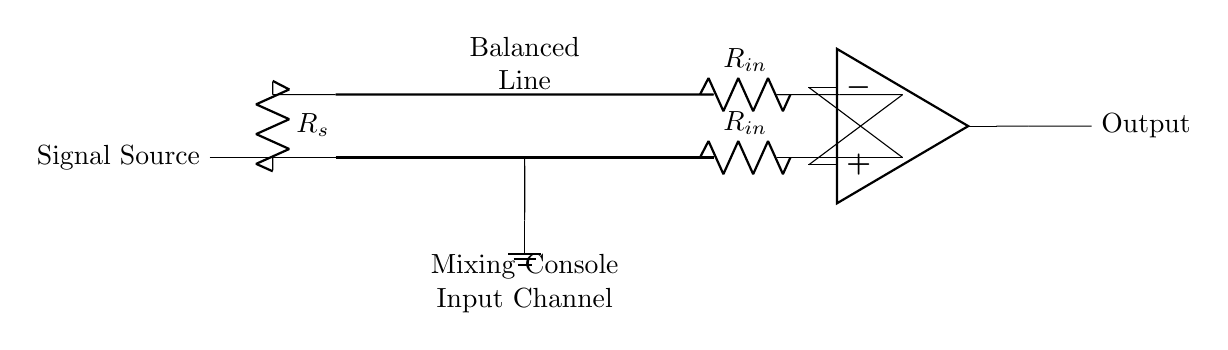What is the role of the resistor labeled as R_s? Resistor R_s, also known as the source resistance, provides a means for the signal source to limit current or adjust gain before the signal enters the balanced line.
Answer: Source resistance What does the label "Balanced Line" imply in this circuit? The "Balanced Line" label indicates that the audio signal is transmitted over two conductors to cancel out noise and interference, allowing for a clearer audio signal when it reaches the input stage.
Answer: Noise reduction How many input resistors are present in the input stage? There are two input resistors labeled as R_in in the input stage, one for each leg of the balanced input configuration.
Answer: Two What type of circuit is this diagram representing? The diagram represents a parallel circuit configuration, specifically designed for balanced audio connections often used in audio mixing consoles.
Answer: Parallel Why is a differential amplifier used in this circuit? A differential amplifier is used to amplify the difference between the two input signals while rejecting any common noise or interference that may have been picked up along the balanced line, thus maintaining signal integrity.
Answer: Signal integrity What is the final output of the circuit? The final output of the circuit is labeled simply as "Output," which indicates the processed audio signal ready to be sent to the next stage of audio processing or amplification.
Answer: Processed audio signal 